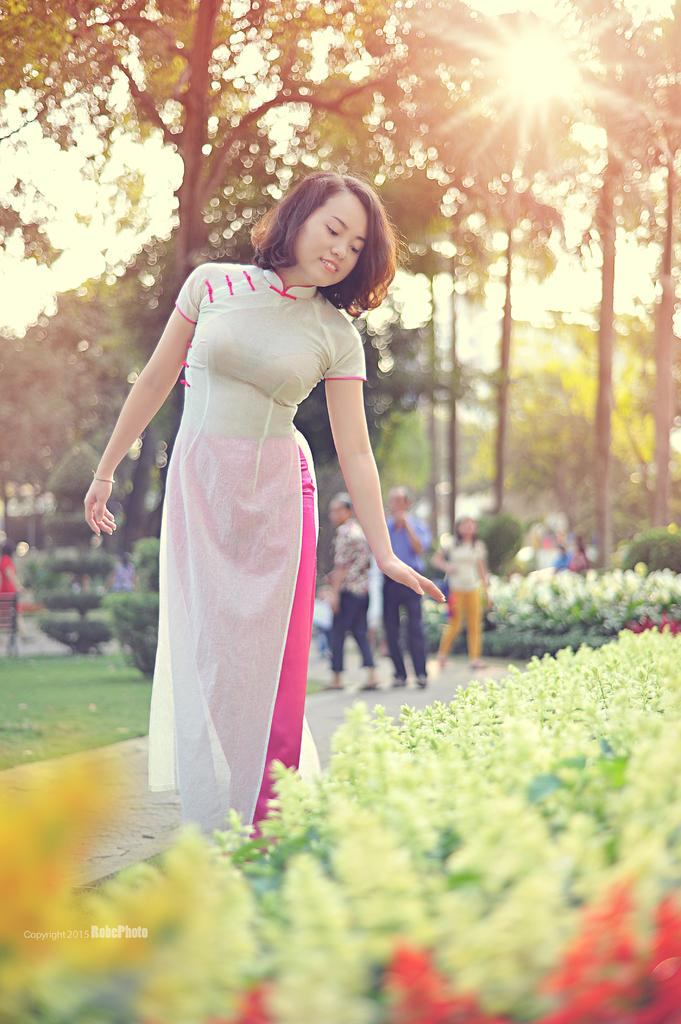What can be seen in the image involving multiple individuals? There is a group of people in the image. What type of natural elements are present in the image? There are plants and trees in the image. Where is the watermark located in the image? The watermark is at the left bottom of the image. What type of trade is being conducted by the ducks in the image? There are no ducks present in the image, so it is not possible to determine if any trade is being conducted. 